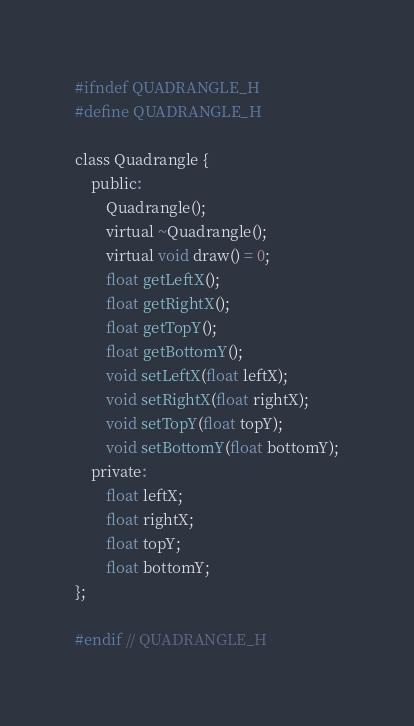<code> <loc_0><loc_0><loc_500><loc_500><_C_>#ifndef QUADRANGLE_H
#define QUADRANGLE_H

class Quadrangle {
    public:
        Quadrangle();
        virtual ~Quadrangle();
        virtual void draw() = 0;
        float getLeftX();
        float getRightX();
        float getTopY();
        float getBottomY();
        void setLeftX(float leftX);
        void setRightX(float rightX);
        void setTopY(float topY);
        void setBottomY(float bottomY);
    private:
        float leftX;
        float rightX;
        float topY;
        float bottomY;
};

#endif // QUADRANGLE_H
</code> 